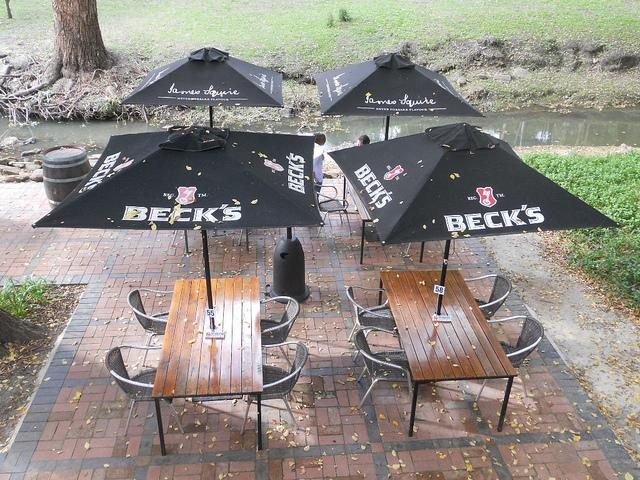What do the umbrellas offer those who sit here?

Choices:
A) shade
B) warmth
C) heat
D) radiation protection shade 